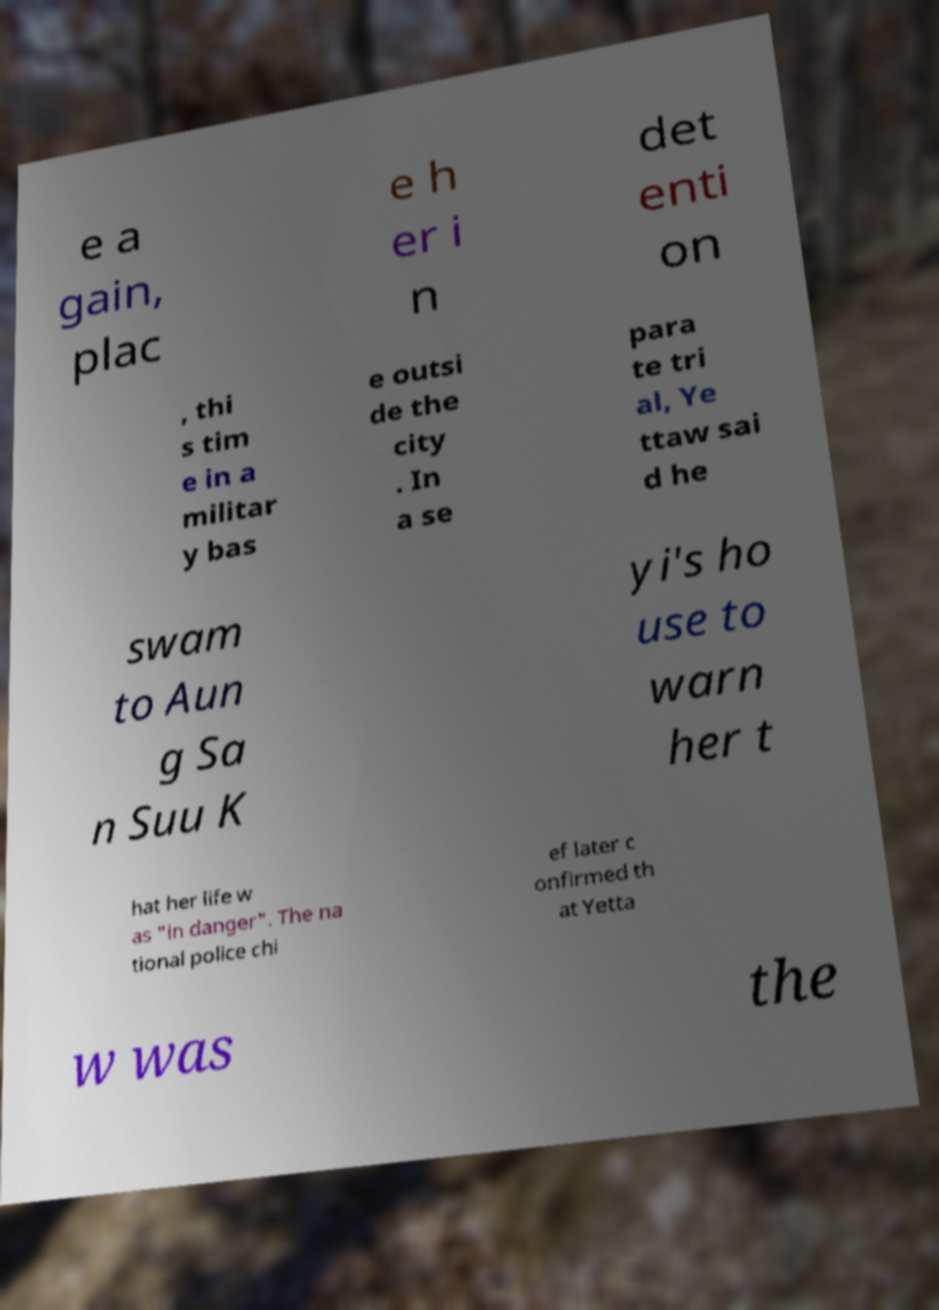I need the written content from this picture converted into text. Can you do that? e a gain, plac e h er i n det enti on , thi s tim e in a militar y bas e outsi de the city . In a se para te tri al, Ye ttaw sai d he swam to Aun g Sa n Suu K yi's ho use to warn her t hat her life w as "in danger". The na tional police chi ef later c onfirmed th at Yetta w was the 